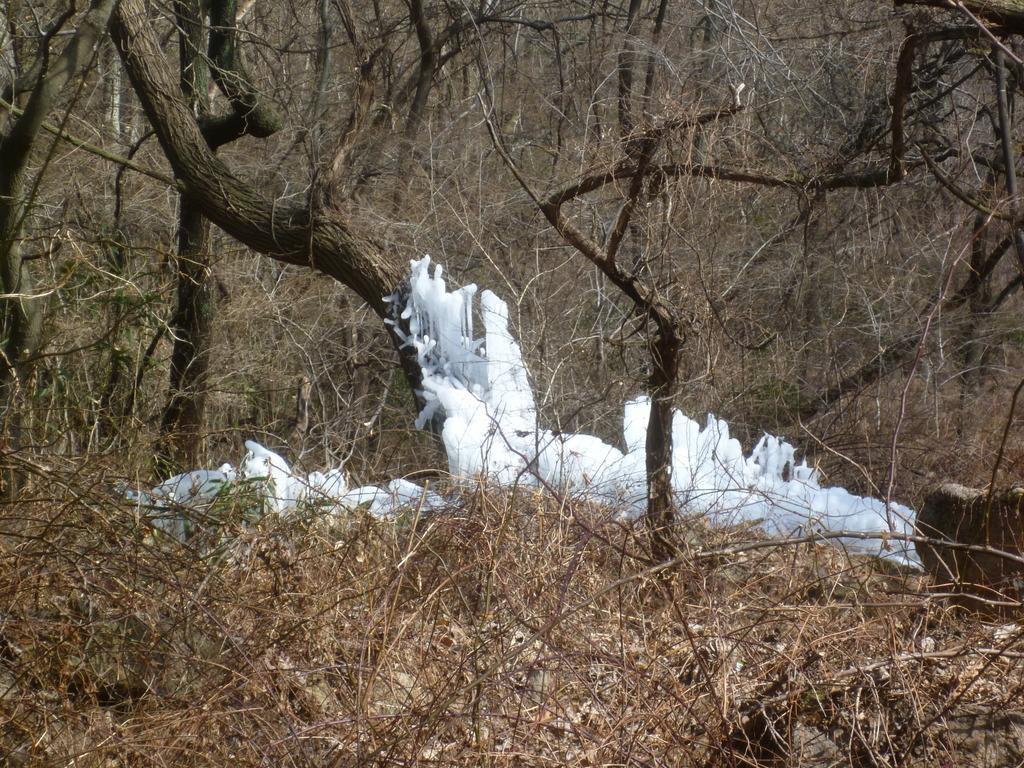Describe this image in one or two sentences. In this image in the middle there are many trees and there is some white color substance. At the bottom there is a dry grass. 